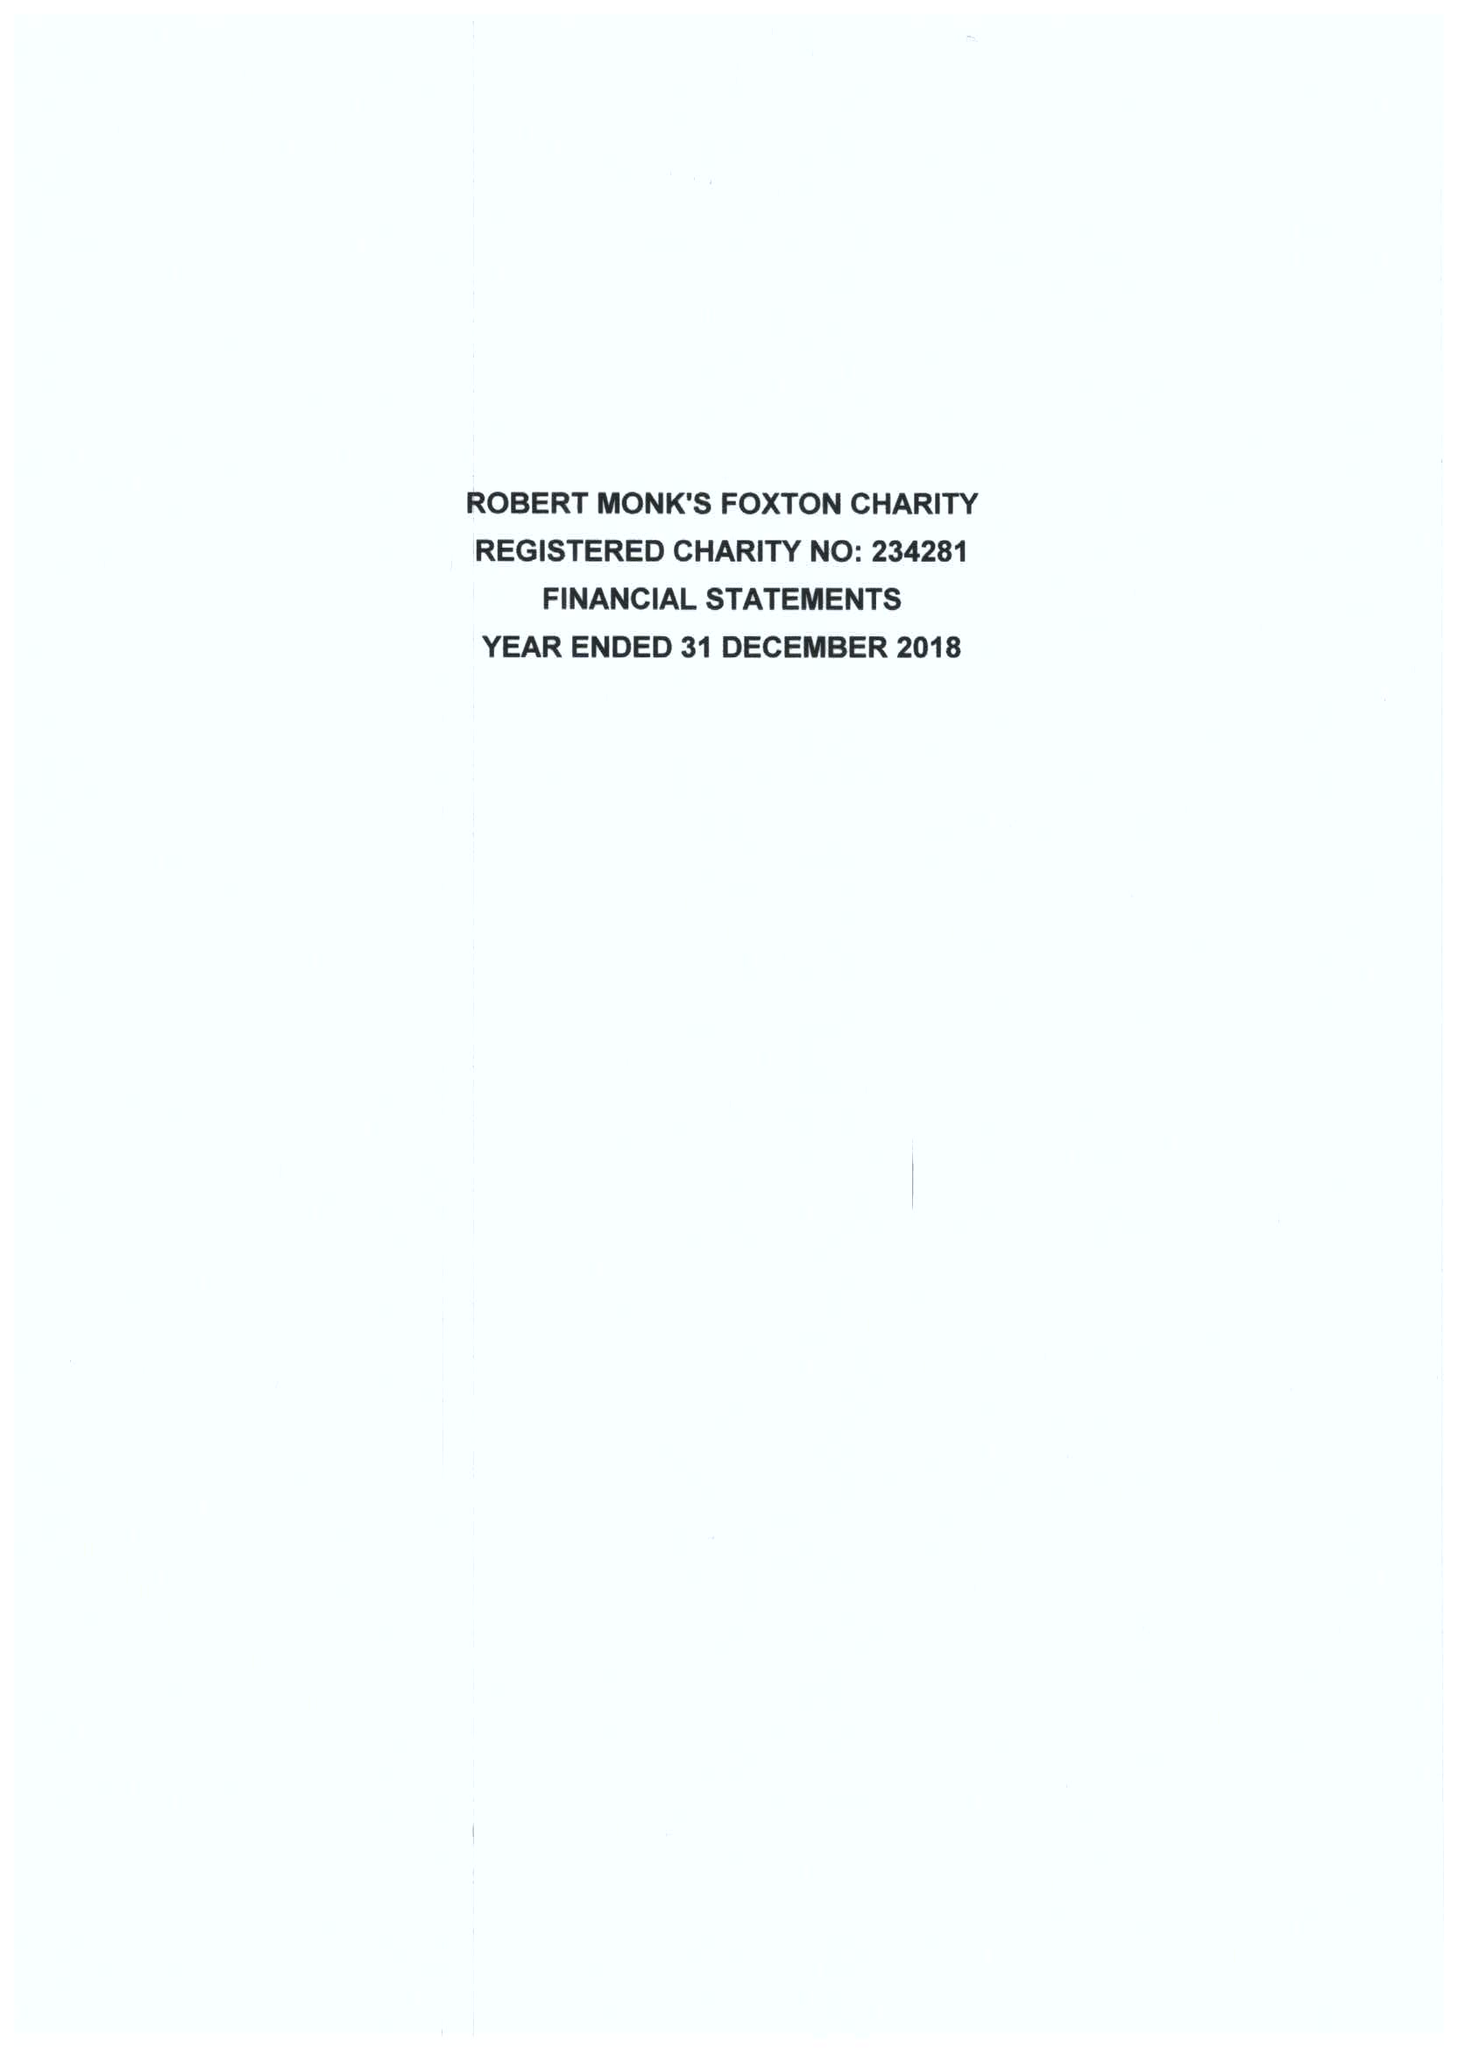What is the value for the spending_annually_in_british_pounds?
Answer the question using a single word or phrase. 26315.00 